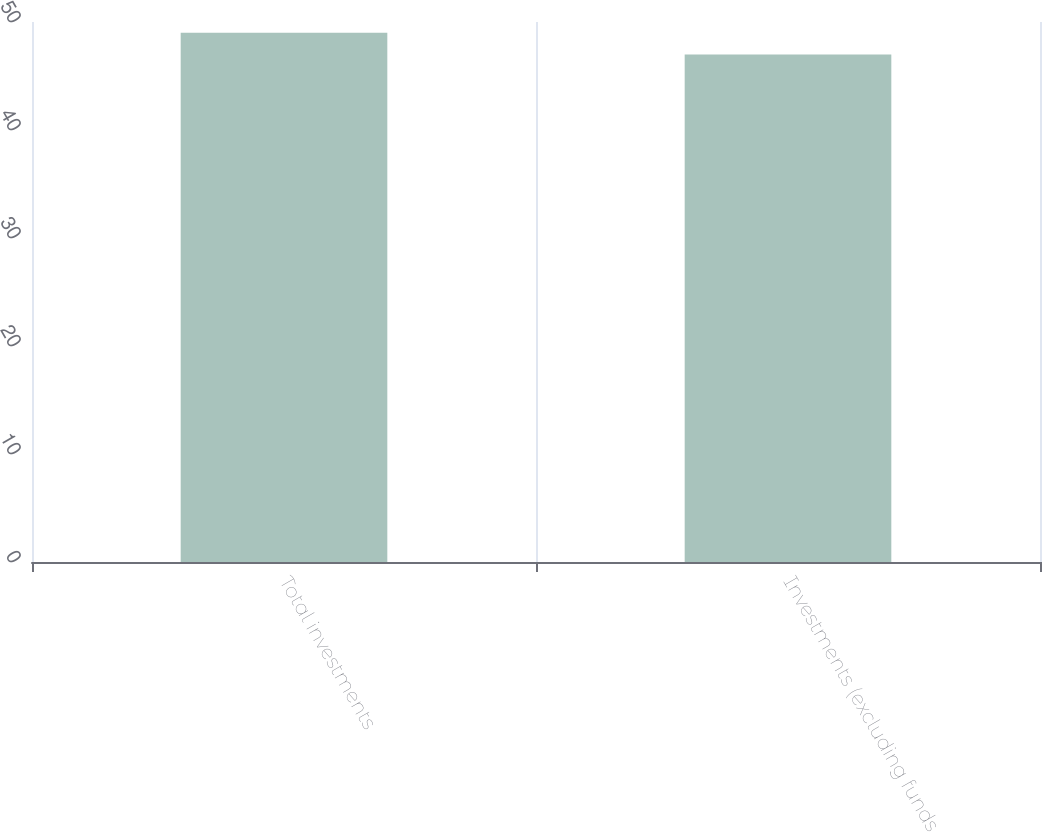Convert chart. <chart><loc_0><loc_0><loc_500><loc_500><bar_chart><fcel>Total investments<fcel>Investments (excluding funds<nl><fcel>49<fcel>47<nl></chart> 